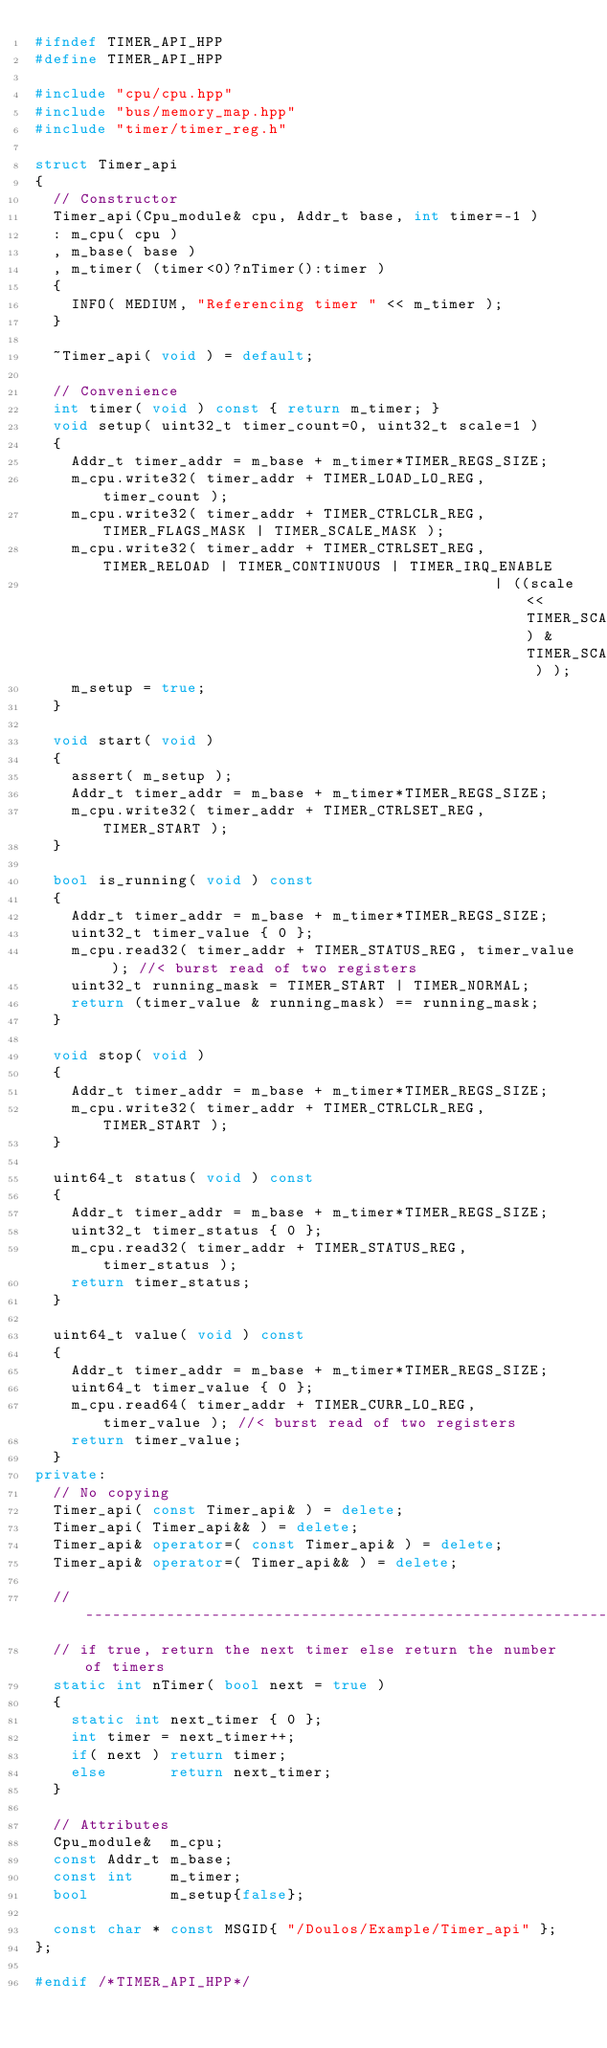<code> <loc_0><loc_0><loc_500><loc_500><_C++_>#ifndef TIMER_API_HPP
#define TIMER_API_HPP

#include "cpu/cpu.hpp"
#include "bus/memory_map.hpp"
#include "timer/timer_reg.h"

struct Timer_api
{
  // Constructor
  Timer_api(Cpu_module& cpu, Addr_t base, int timer=-1 )
  : m_cpu( cpu )
  , m_base( base )
  , m_timer( (timer<0)?nTimer():timer )
  {
    INFO( MEDIUM, "Referencing timer " << m_timer );
  }

  ~Timer_api( void ) = default;

  // Convenience
  int timer( void ) const { return m_timer; }
  void setup( uint32_t timer_count=0, uint32_t scale=1 )
  {
    Addr_t timer_addr = m_base + m_timer*TIMER_REGS_SIZE;
    m_cpu.write32( timer_addr + TIMER_LOAD_LO_REG, timer_count );
    m_cpu.write32( timer_addr + TIMER_CTRLCLR_REG, TIMER_FLAGS_MASK | TIMER_SCALE_MASK );
    m_cpu.write32( timer_addr + TIMER_CTRLSET_REG, TIMER_RELOAD | TIMER_CONTINUOUS | TIMER_IRQ_ENABLE
                                                   | ((scale<<TIMER_SCALE_LSB) & TIMER_SCALE_MASK ) );
    m_setup = true;
  }

  void start( void )
  {
    assert( m_setup );
    Addr_t timer_addr = m_base + m_timer*TIMER_REGS_SIZE;
    m_cpu.write32( timer_addr + TIMER_CTRLSET_REG, TIMER_START );
  }

  bool is_running( void ) const
  {
    Addr_t timer_addr = m_base + m_timer*TIMER_REGS_SIZE;
    uint32_t timer_value { 0 };
    m_cpu.read32( timer_addr + TIMER_STATUS_REG, timer_value ); //< burst read of two registers
    uint32_t running_mask = TIMER_START | TIMER_NORMAL;
    return (timer_value & running_mask) == running_mask;
  }

  void stop( void )
  {
    Addr_t timer_addr = m_base + m_timer*TIMER_REGS_SIZE;
    m_cpu.write32( timer_addr + TIMER_CTRLCLR_REG, TIMER_START );
  }

  uint64_t status( void ) const
  {
    Addr_t timer_addr = m_base + m_timer*TIMER_REGS_SIZE;
    uint32_t timer_status { 0 };
    m_cpu.read32( timer_addr + TIMER_STATUS_REG, timer_status );
    return timer_status;
  }

  uint64_t value( void ) const
  {
    Addr_t timer_addr = m_base + m_timer*TIMER_REGS_SIZE;
    uint64_t timer_value { 0 };
    m_cpu.read64( timer_addr + TIMER_CURR_LO_REG, timer_value ); //< burst read of two registers
    return timer_value;
  }
private:
  // No copying
  Timer_api( const Timer_api& ) = delete;
  Timer_api( Timer_api&& ) = delete;
  Timer_api& operator=( const Timer_api& ) = delete;
  Timer_api& operator=( Timer_api&& ) = delete;

  //------------------------------------------------------------------------------
  // if true, return the next timer else return the number of timers
  static int nTimer( bool next = true )
  {
    static int next_timer { 0 };
    int timer = next_timer++;
    if( next ) return timer;
    else       return next_timer;
  }

  // Attributes
  Cpu_module&  m_cpu;
  const Addr_t m_base;
  const int    m_timer;
  bool         m_setup{false};

  const char * const MSGID{ "/Doulos/Example/Timer_api" };
};

#endif /*TIMER_API_HPP*/
</code> 